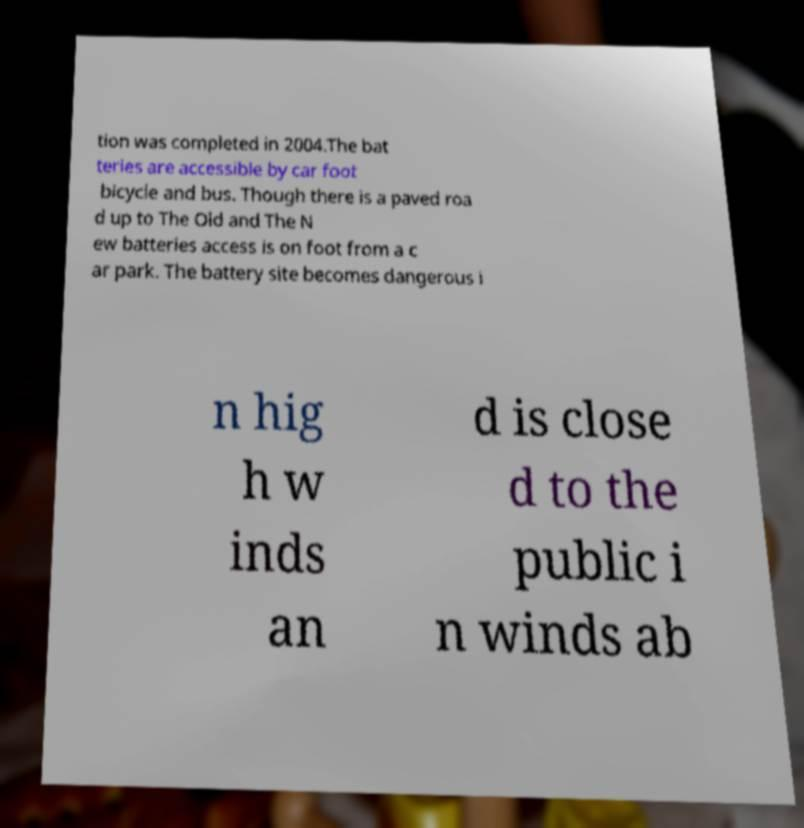Please read and relay the text visible in this image. What does it say? tion was completed in 2004.The bat teries are accessible by car foot bicycle and bus. Though there is a paved roa d up to The Old and The N ew batteries access is on foot from a c ar park. The battery site becomes dangerous i n hig h w inds an d is close d to the public i n winds ab 